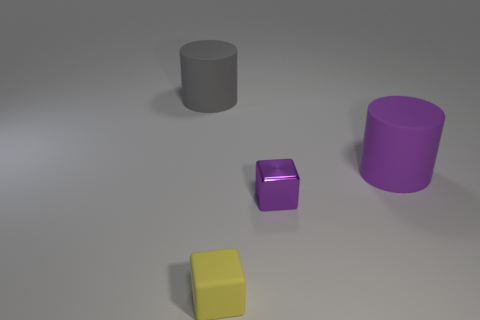There is a tiny yellow rubber cube that is in front of the large object on the right side of the gray thing; are there any gray rubber cylinders that are behind it?
Provide a short and direct response. Yes. What number of small objects are yellow rubber blocks or metallic cubes?
Provide a succinct answer. 2. The other thing that is the same size as the gray matte object is what color?
Make the answer very short. Purple. There is a large gray cylinder; how many large matte cylinders are right of it?
Provide a succinct answer. 1. Are there any purple things that have the same material as the yellow thing?
Provide a succinct answer. Yes. The big matte thing that is the same color as the tiny shiny block is what shape?
Provide a short and direct response. Cylinder. There is a big matte object that is in front of the big gray cylinder; what is its color?
Give a very brief answer. Purple. Are there the same number of gray rubber things that are to the right of the small rubber block and purple objects on the right side of the large purple rubber cylinder?
Give a very brief answer. Yes. The cylinder that is behind the matte cylinder that is in front of the big gray rubber cylinder is made of what material?
Your response must be concise. Rubber. How many things are tiny yellow objects or tiny yellow rubber cubes in front of the purple cylinder?
Ensure brevity in your answer.  1. 